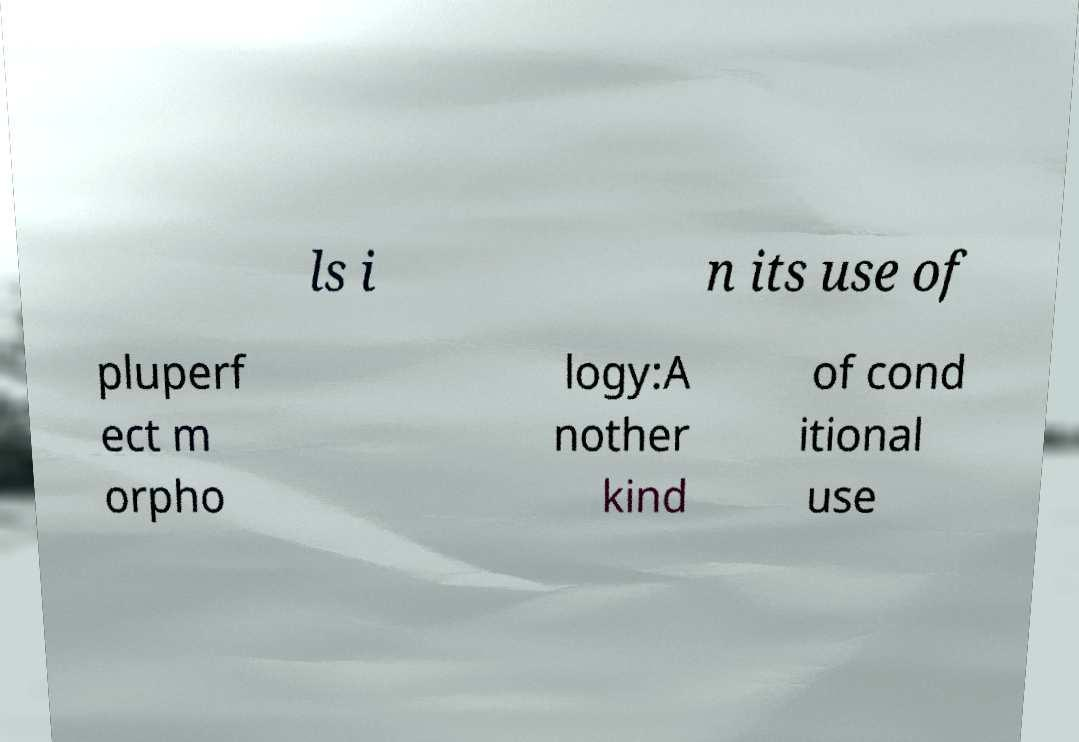Can you read and provide the text displayed in the image?This photo seems to have some interesting text. Can you extract and type it out for me? ls i n its use of pluperf ect m orpho logy:A nother kind of cond itional use 